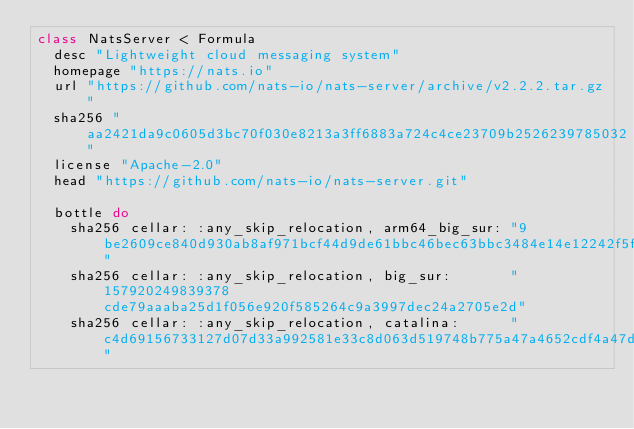Convert code to text. <code><loc_0><loc_0><loc_500><loc_500><_Ruby_>class NatsServer < Formula
  desc "Lightweight cloud messaging system"
  homepage "https://nats.io"
  url "https://github.com/nats-io/nats-server/archive/v2.2.2.tar.gz"
  sha256 "aa2421da9c0605d3bc70f030e8213a3ff6883a724c4ce23709b2526239785032"
  license "Apache-2.0"
  head "https://github.com/nats-io/nats-server.git"

  bottle do
    sha256 cellar: :any_skip_relocation, arm64_big_sur: "9be2609ce840d930ab8af971bcf44d9de61bbc46bec63bbc3484e14e12242f5f"
    sha256 cellar: :any_skip_relocation, big_sur:       "157920249839378cde79aaaba25d1f056e920f585264c9a3997dec24a2705e2d"
    sha256 cellar: :any_skip_relocation, catalina:      "c4d69156733127d07d33a992581e33c8d063d519748b775a47a4652cdf4a47d5"</code> 